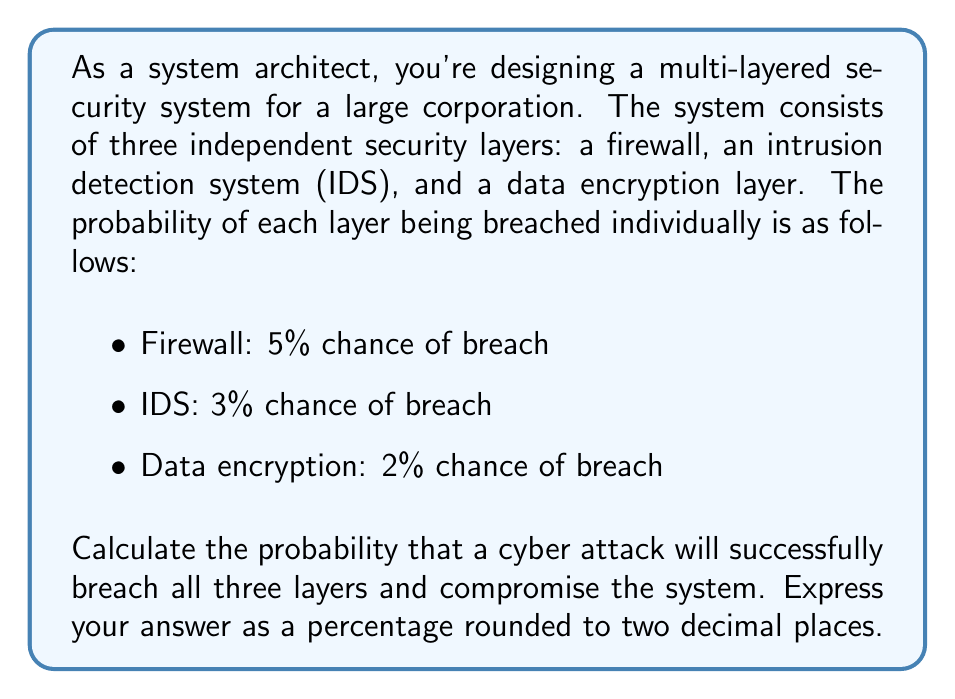Show me your answer to this math problem. To solve this problem, we need to use the concept of independent events and probability multiplication.

1) First, let's define the events:
   A = Firewall is breached
   B = IDS is breached
   C = Data encryption is breached

2) We're given the probabilities:
   P(A) = 5% = 0.05
   P(B) = 3% = 0.03
   P(C) = 2% = 0.02

3) For a successful attack, all three layers must be breached. Since the events are independent, we multiply the probabilities:

   $$P(\text{successful attack}) = P(A \cap B \cap C) = P(A) \times P(B) \times P(C)$$

4) Substituting the values:

   $$P(\text{successful attack}) = 0.05 \times 0.03 \times 0.02$$

5) Calculating:

   $$P(\text{successful attack}) = 0.00003 = 3 \times 10^{-5}$$

6) Converting to a percentage:

   $$3 \times 10^{-5} \times 100\% = 0.003\%$$

Therefore, the probability of a successful cyber attack breaching all three layers is 0.003%.
Answer: 0.003% 